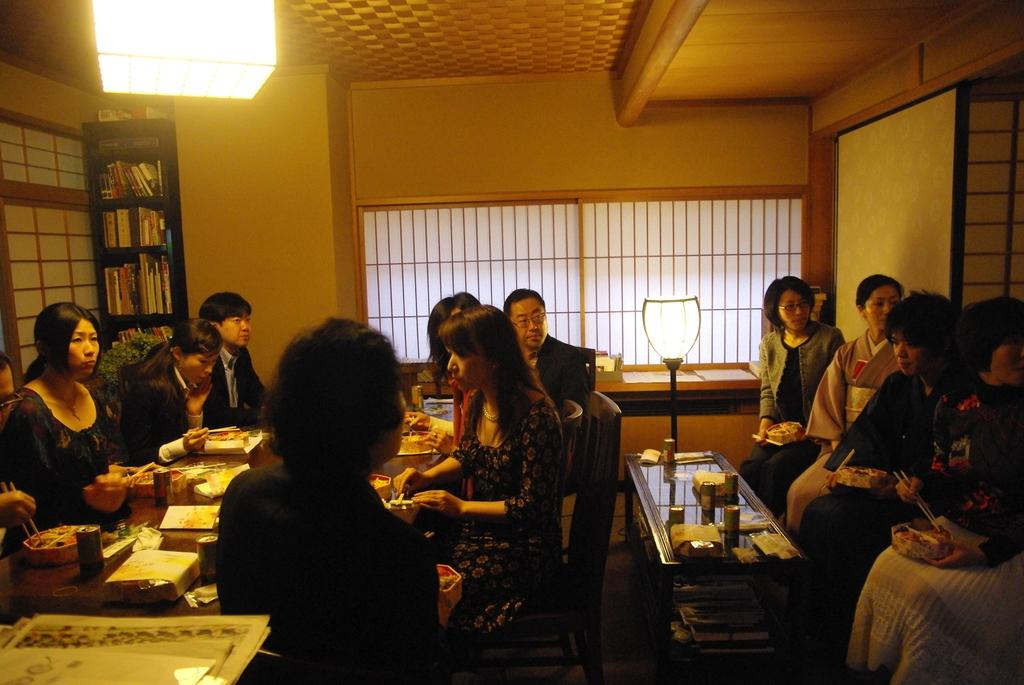What is happening in the image involving a group of people? There is a group of people in the image, and they are seated on chairs. What can be seen on the table in the image? There are food plates, bowls, and glasses on the table in the image. What type of chain can be seen connecting the people in the image? There is no chain present in the image; the people are seated on chairs independently. 